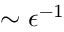<formula> <loc_0><loc_0><loc_500><loc_500>\sim \epsilon ^ { - 1 }</formula> 